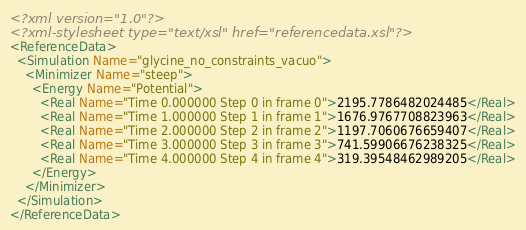Convert code to text. <code><loc_0><loc_0><loc_500><loc_500><_XML_><?xml version="1.0"?>
<?xml-stylesheet type="text/xsl" href="referencedata.xsl"?>
<ReferenceData>
  <Simulation Name="glycine_no_constraints_vacuo">
    <Minimizer Name="steep">
      <Energy Name="Potential">
        <Real Name="Time 0.000000 Step 0 in frame 0">2195.7786482024485</Real>
        <Real Name="Time 1.000000 Step 1 in frame 1">1676.9767708823963</Real>
        <Real Name="Time 2.000000 Step 2 in frame 2">1197.7060676659407</Real>
        <Real Name="Time 3.000000 Step 3 in frame 3">741.59906676238325</Real>
        <Real Name="Time 4.000000 Step 4 in frame 4">319.39548462989205</Real>
      </Energy>
    </Minimizer>
  </Simulation>
</ReferenceData>
</code> 